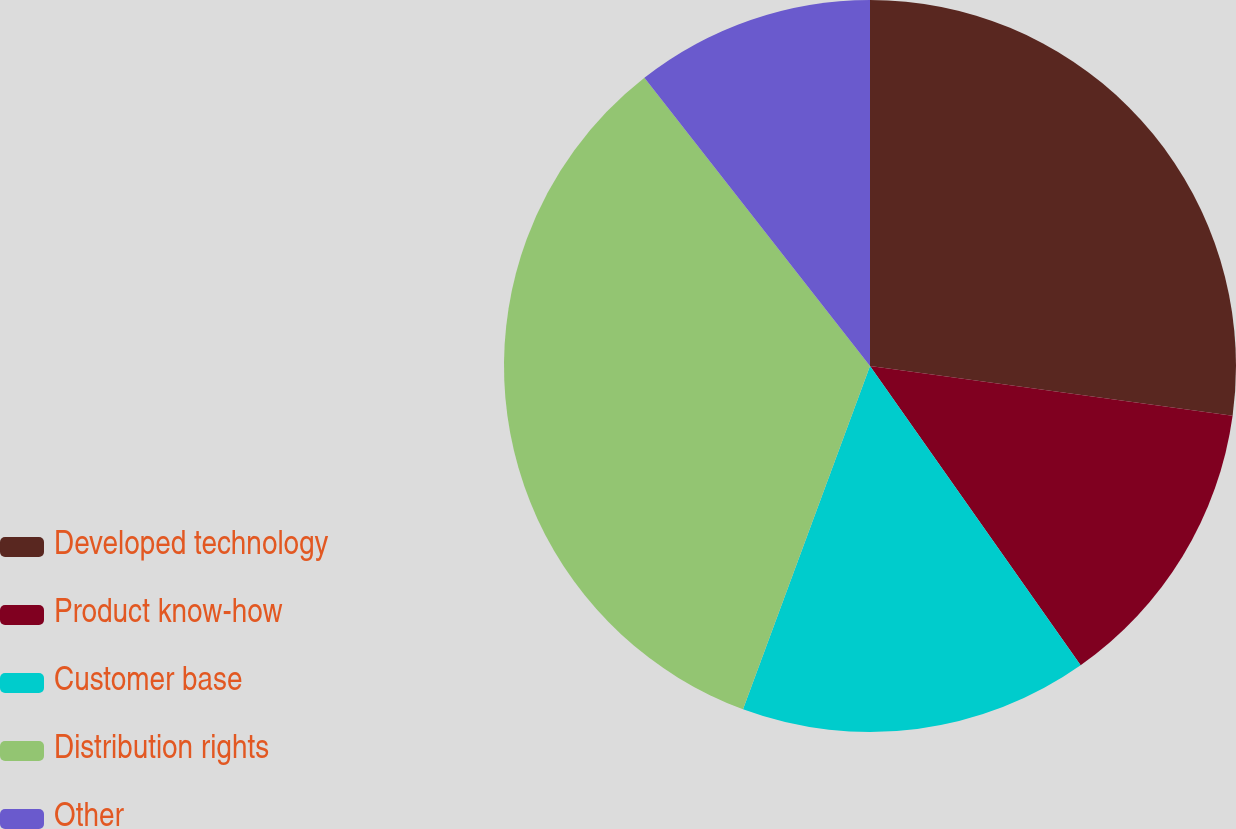Convert chart to OTSL. <chart><loc_0><loc_0><loc_500><loc_500><pie_chart><fcel>Developed technology<fcel>Product know-how<fcel>Customer base<fcel>Distribution rights<fcel>Other<nl><fcel>27.17%<fcel>13.07%<fcel>15.4%<fcel>33.79%<fcel>10.57%<nl></chart> 